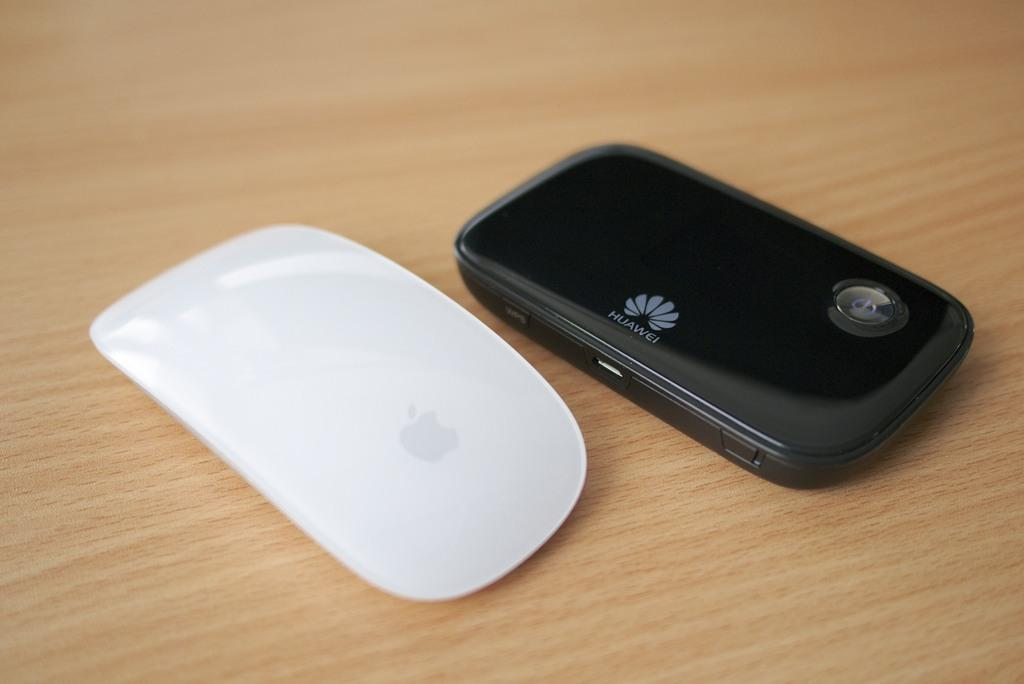<image>
Describe the image concisely. A black HUAWEI phone and a white computer mouse are on a table. 